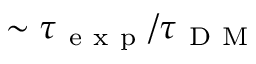Convert formula to latex. <formula><loc_0><loc_0><loc_500><loc_500>\sim \tau _ { e x p } / \tau _ { D M }</formula> 